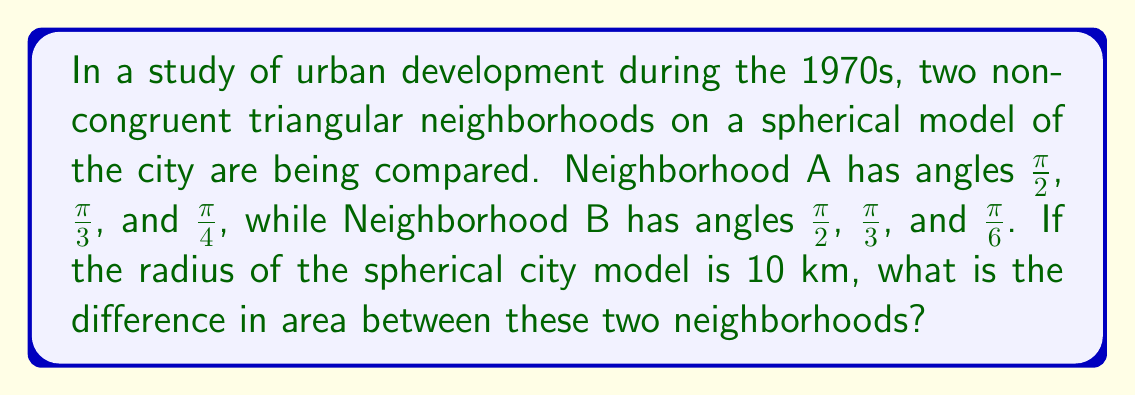Could you help me with this problem? To solve this problem, we'll use the formula for the area of a spherical triangle:

$$ A = R^2(\alpha + \beta + \gamma - \pi) $$

Where $R$ is the radius of the sphere, and $\alpha$, $\beta$, and $\gamma$ are the angles of the triangle in radians.

Step 1: Calculate the area of Neighborhood A
$$ A_A = 10^2 (\frac{\pi}{2} + \frac{\pi}{3} + \frac{\pi}{4} - \pi) $$
$$ A_A = 100 (\frac{6\pi + 4\pi + 3\pi - 12\pi}{12}) $$
$$ A_A = 100 (\frac{\pi}{12}) = \frac{25\pi}{3} \approx 26.18 \text{ km}^2 $$

Step 2: Calculate the area of Neighborhood B
$$ A_B = 10^2 (\frac{\pi}{2} + \frac{\pi}{3} + \frac{\pi}{6} - \pi) $$
$$ A_B = 100 (\frac{6\pi + 4\pi + 2\pi - 12\pi}{12}) $$
$$ A_B = 0 \text{ km}^2 $$

Step 3: Calculate the difference in area
$$ \text{Difference} = A_A - A_B = \frac{25\pi}{3} - 0 = \frac{25\pi}{3} \approx 26.18 \text{ km}^2 $$
Answer: $\frac{25\pi}{3}$ km² 